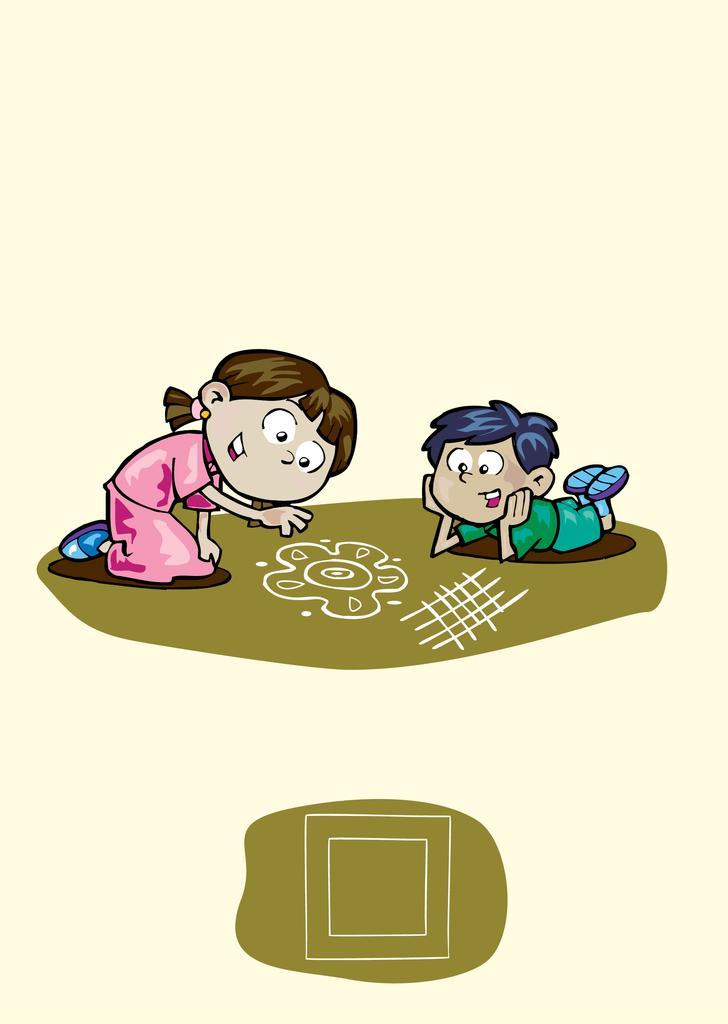Please provide a concise description of this image. I see this is an animated picture in which I see a girl who is wearing pink color dress and I see a boy who is lying and I see the rangoli on the brown color surface. 